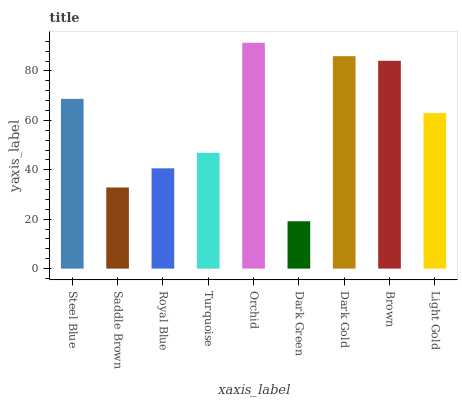Is Saddle Brown the minimum?
Answer yes or no. No. Is Saddle Brown the maximum?
Answer yes or no. No. Is Steel Blue greater than Saddle Brown?
Answer yes or no. Yes. Is Saddle Brown less than Steel Blue?
Answer yes or no. Yes. Is Saddle Brown greater than Steel Blue?
Answer yes or no. No. Is Steel Blue less than Saddle Brown?
Answer yes or no. No. Is Light Gold the high median?
Answer yes or no. Yes. Is Light Gold the low median?
Answer yes or no. Yes. Is Royal Blue the high median?
Answer yes or no. No. Is Dark Green the low median?
Answer yes or no. No. 